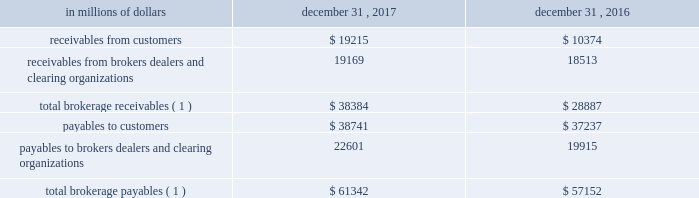12 .
Brokerage receivables and brokerage payables citi has receivables and payables for financial instruments sold to and purchased from brokers , dealers and customers , which arise in the ordinary course of business .
Citi is exposed to risk of loss from the inability of brokers , dealers or customers to pay for purchases or to deliver the financial instruments sold , in which case citi would have to sell or purchase the financial instruments at prevailing market prices .
Credit risk is reduced to the extent that an exchange or clearing organization acts as a counterparty to the transaction and replaces the broker , dealer or customer in question .
Citi seeks to protect itself from the risks associated with customer activities by requiring customers to maintain margin collateral in compliance with regulatory and internal guidelines .
Margin levels are monitored daily , and customers deposit additional collateral as required .
Where customers cannot meet collateral requirements , citi may liquidate sufficient underlying financial instruments to bring the customer into compliance with the required margin level .
Exposure to credit risk is impacted by market volatility , which may impair the ability of clients to satisfy their obligations to citi .
Credit limits are established and closely monitored for customers and for brokers and dealers engaged in forwards , futures and other transactions deemed to be credit sensitive .
Brokerage receivables and brokerage payables consisted of the following: .
Payables to brokers , dealers and clearing organizations 22601 19915 total brokerage payables ( 1 ) $ 61342 $ 57152 ( 1 ) includes brokerage receivables and payables recorded by citi broker- dealer entities that are accounted for in accordance with the aicpa accounting guide for brokers and dealers in securities as codified in asc 940-320. .
As of december 31 2017 what is the ratio of receivables from brokers dealers and clearing organizations to payables to brokers dealers and clearing organizations? 
Rationale: systemically if there is a large market disruption with less receivables from the brokerage industry than payables it is disadvantageous
Computations: (19169 / 22601)
Answer: 0.84815. 